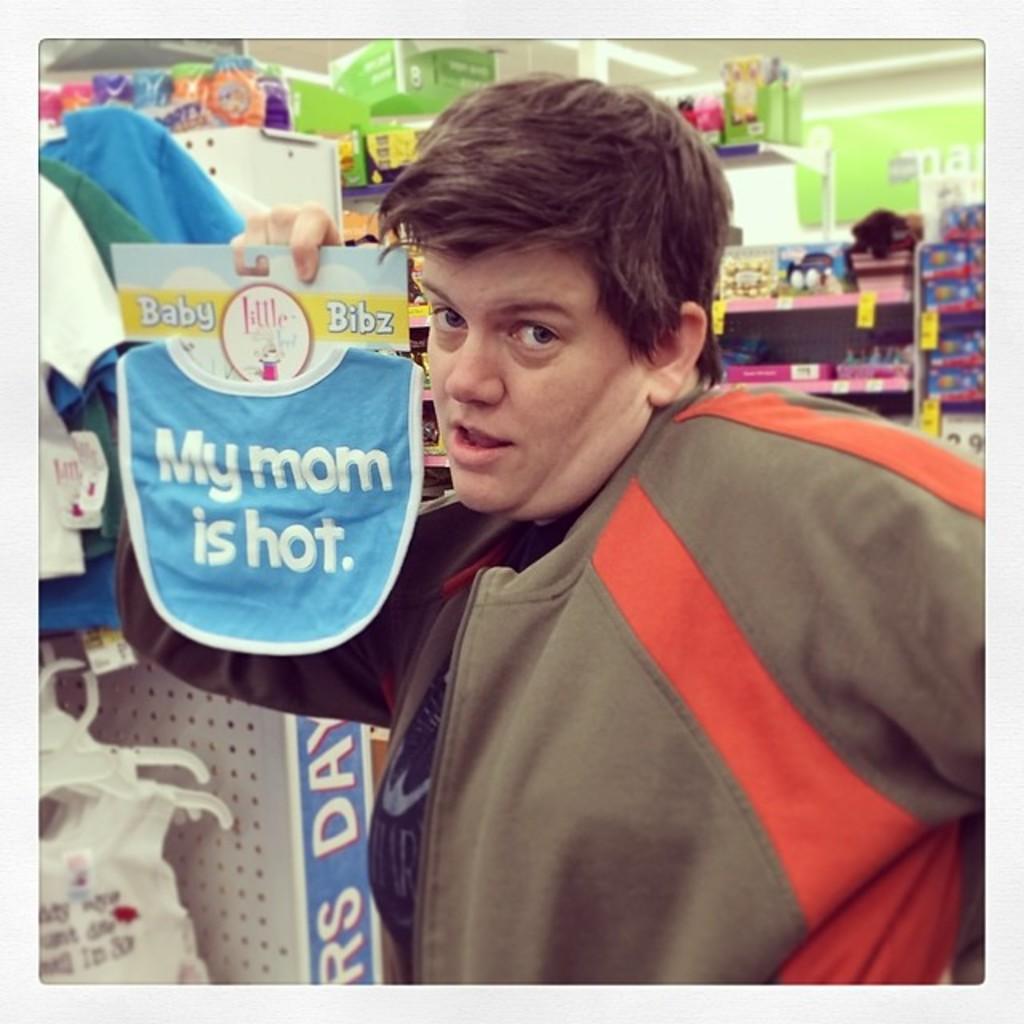What does the bib say?
Provide a succinct answer. My mom is hot. What is the name of the bib company?
Give a very brief answer. Baby bibz. 